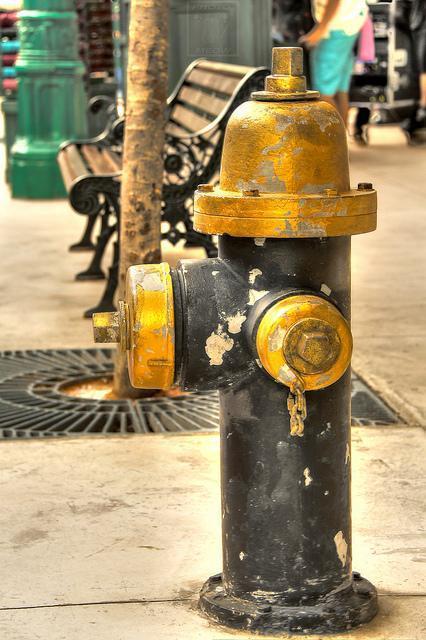How many people are there?
Give a very brief answer. 2. How many elephants have 2 people riding them?
Give a very brief answer. 0. 